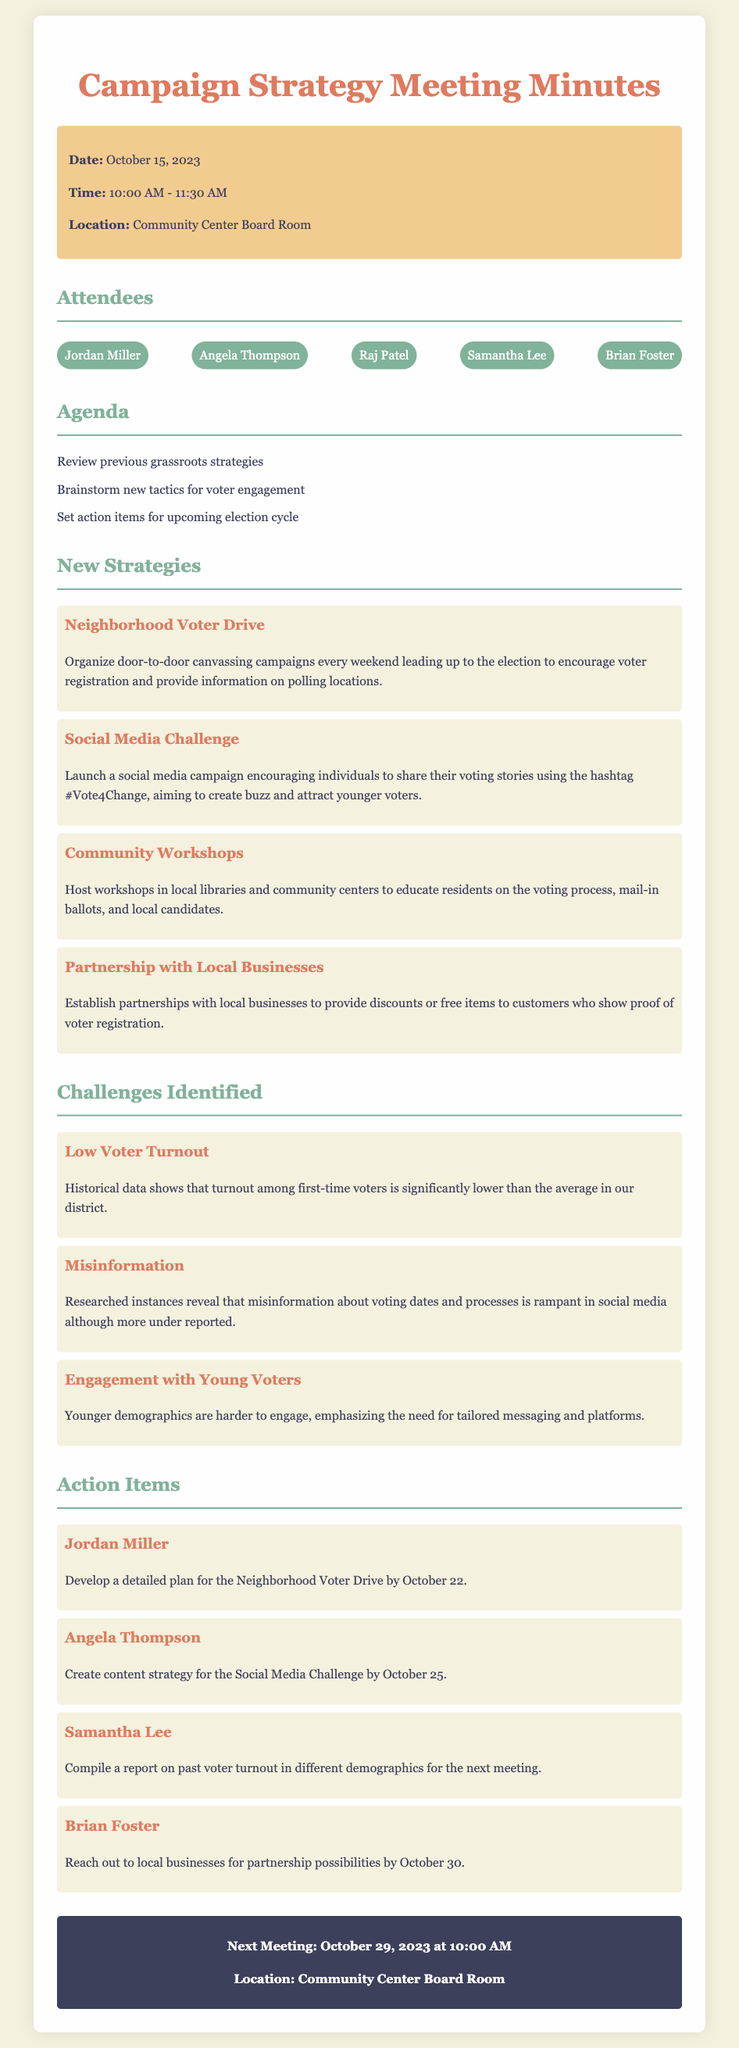What is the date of the meeting? The meeting took place on October 15, 2023, as mentioned in the info box.
Answer: October 15, 2023 Who is responsible for developing the plan for the Neighborhood Voter Drive? Jordan Miller is tasked with this action item, indicated under Action Items.
Answer: Jordan Miller What challenge is associated with young voters? Engagement with Young Voters is identified as a challenge in the document.
Answer: Engagement with Young Voters When is the next meeting scheduled? The next meeting is set to take place on October 29, 2023, as specified at the end of the document.
Answer: October 29, 2023 What social media campaign is proposed? The Social Media Challenge is mentioned as a proposed new strategy for voter engagement.
Answer: Social Media Challenge How many attendees are listed in the document? There are five attendees listed in the attendees section, showing their names.
Answer: Five What action item must Angela Thompson complete? Angela Thompson needs to create a content strategy for the Social Media Challenge.
Answer: Create content strategy for the Social Media Challenge What is the primary goal of the Neighborhood Voter Drive? The primary goal is to encourage voter registration and provide information on polling locations.
Answer: Encourage voter registration and provide information on polling locations What is a significant challenge noted about first-time voters? It is noted that historical data shows significantly lower turnout among first-time voters.
Answer: Low Voter Turnout 